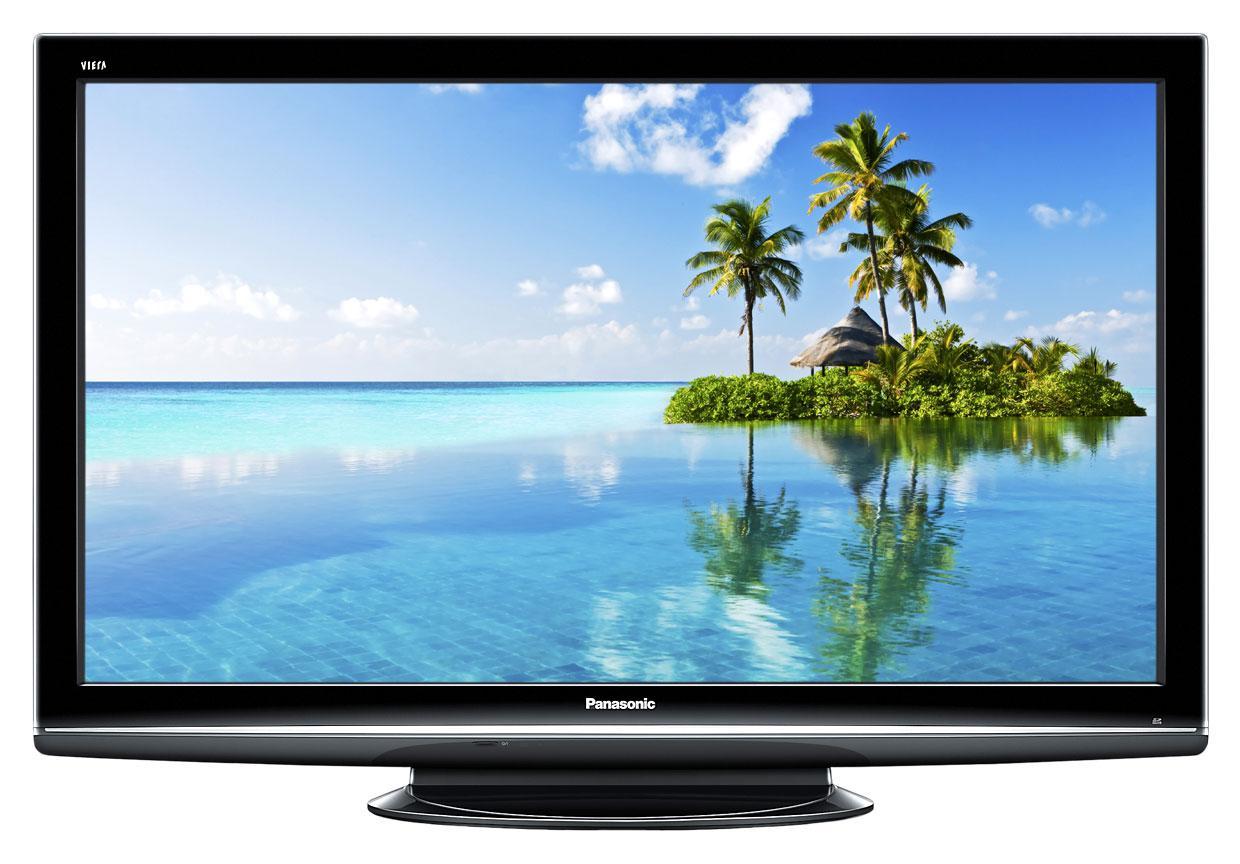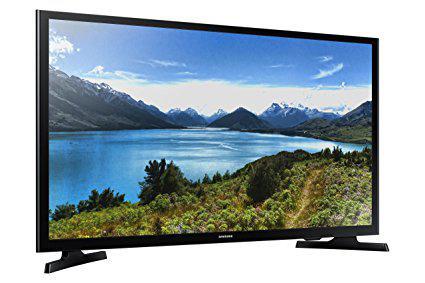The first image is the image on the left, the second image is the image on the right. Considering the images on both sides, is "One screen is tilted to the right and shows mountains in front of a lake, and the other screen is viewed head-on and shows a different landscape scene." valid? Answer yes or no. Yes. The first image is the image on the left, the second image is the image on the right. Evaluate the accuracy of this statement regarding the images: "One of the screens is showing a tropical scene.". Is it true? Answer yes or no. Yes. 